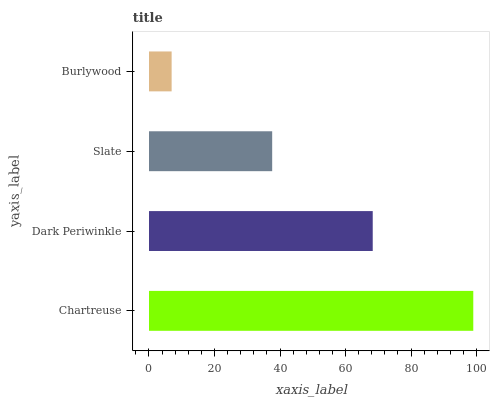Is Burlywood the minimum?
Answer yes or no. Yes. Is Chartreuse the maximum?
Answer yes or no. Yes. Is Dark Periwinkle the minimum?
Answer yes or no. No. Is Dark Periwinkle the maximum?
Answer yes or no. No. Is Chartreuse greater than Dark Periwinkle?
Answer yes or no. Yes. Is Dark Periwinkle less than Chartreuse?
Answer yes or no. Yes. Is Dark Periwinkle greater than Chartreuse?
Answer yes or no. No. Is Chartreuse less than Dark Periwinkle?
Answer yes or no. No. Is Dark Periwinkle the high median?
Answer yes or no. Yes. Is Slate the low median?
Answer yes or no. Yes. Is Slate the high median?
Answer yes or no. No. Is Dark Periwinkle the low median?
Answer yes or no. No. 